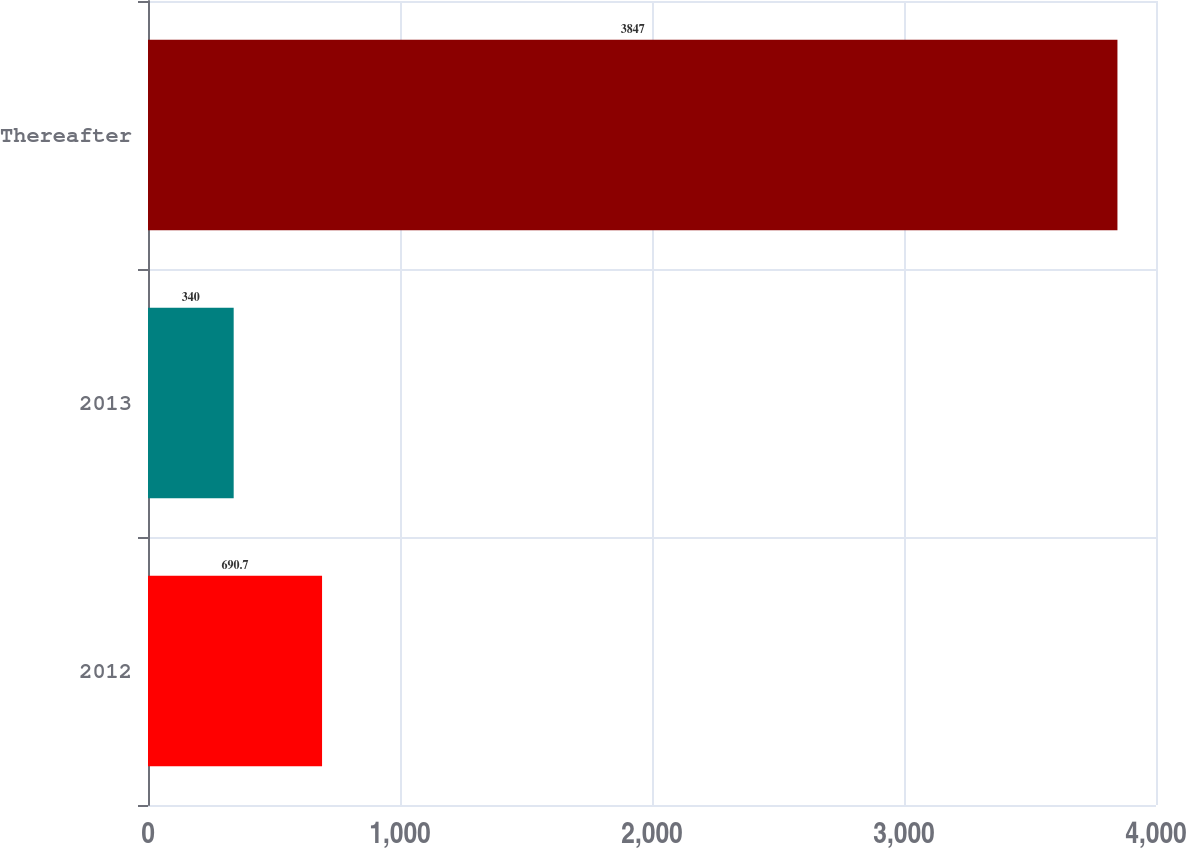Convert chart. <chart><loc_0><loc_0><loc_500><loc_500><bar_chart><fcel>2012<fcel>2013<fcel>Thereafter<nl><fcel>690.7<fcel>340<fcel>3847<nl></chart> 